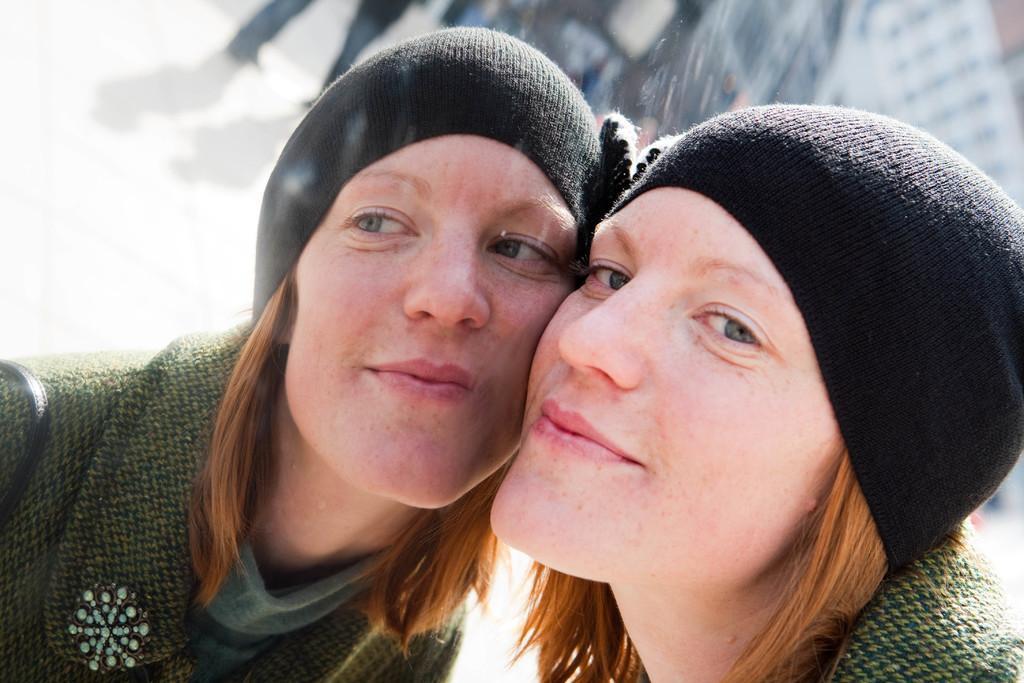Can you describe this image briefly? In this picture I can observe two women who are looking similar to each other. They are wearing green color sweater and black color cap on their heads. The background is blurred. 